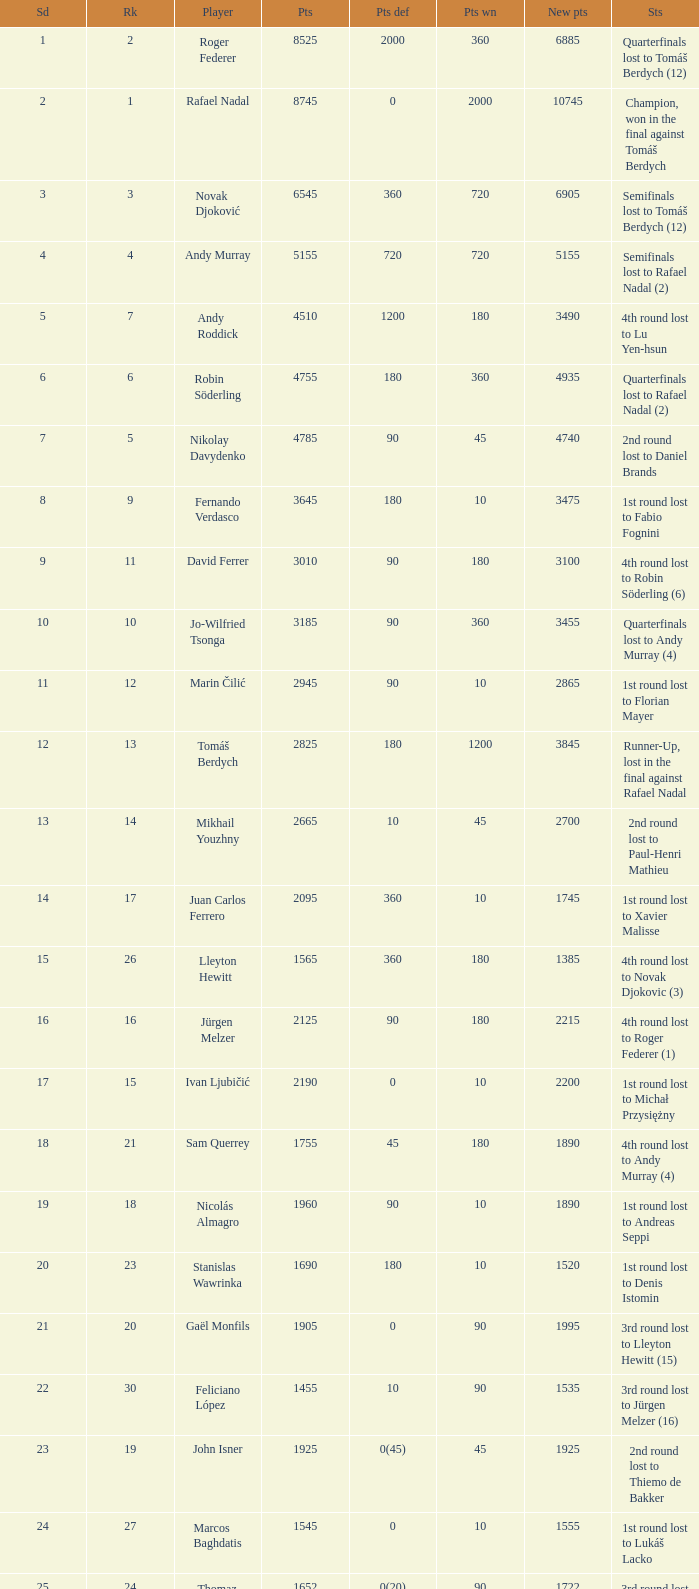Name the points won for 1230 90.0. 